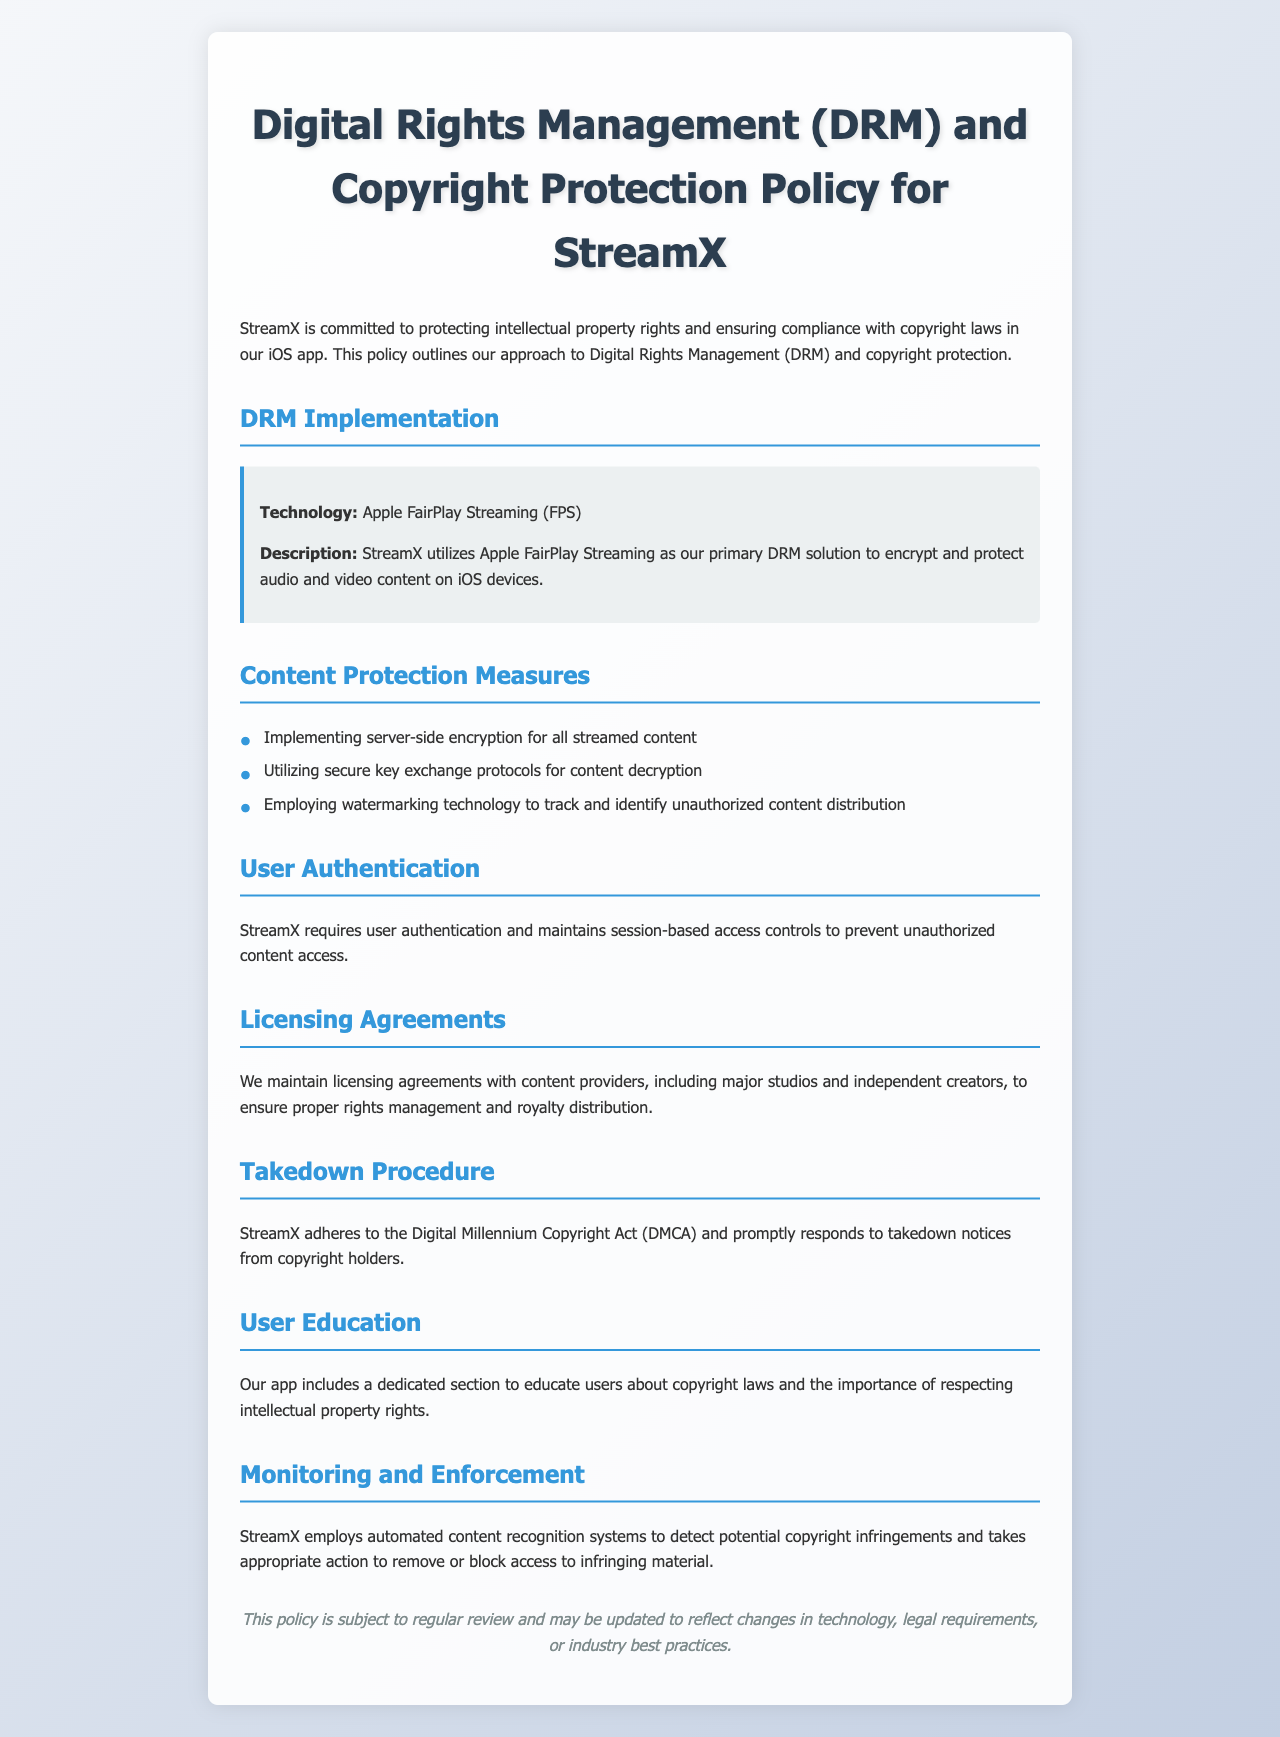What is the main DRM technology used by StreamX? The document states that StreamX utilizes Apple FairPlay Streaming as its primary DRM solution.
Answer: Apple FairPlay Streaming What is the purpose of watermarking technology as mentioned in the policy? Watermarking technology is employed to track and identify unauthorized content distribution.
Answer: Track and identify unauthorized content distribution Which law does StreamX adhere to for handling takedown notices? The policy mentions that StreamX adheres to the Digital Millennium Copyright Act (DMCA).
Answer: Digital Millennium Copyright Act What is required from users to prevent unauthorized content access? StreamX requires user authentication and maintains session-based access controls.
Answer: User authentication What is included in the app to educate users about copyright? The app includes a dedicated section to educate users about copyright laws.
Answer: Dedicated section for copyright education Why does StreamX maintain licensing agreements? The agreements are maintained to ensure proper rights management and royalty distribution.
Answer: Proper rights management and royalty distribution What type of system does StreamX employ to detect copyright infringements? The document states that StreamX employs automated content recognition systems.
Answer: Automated content recognition systems 